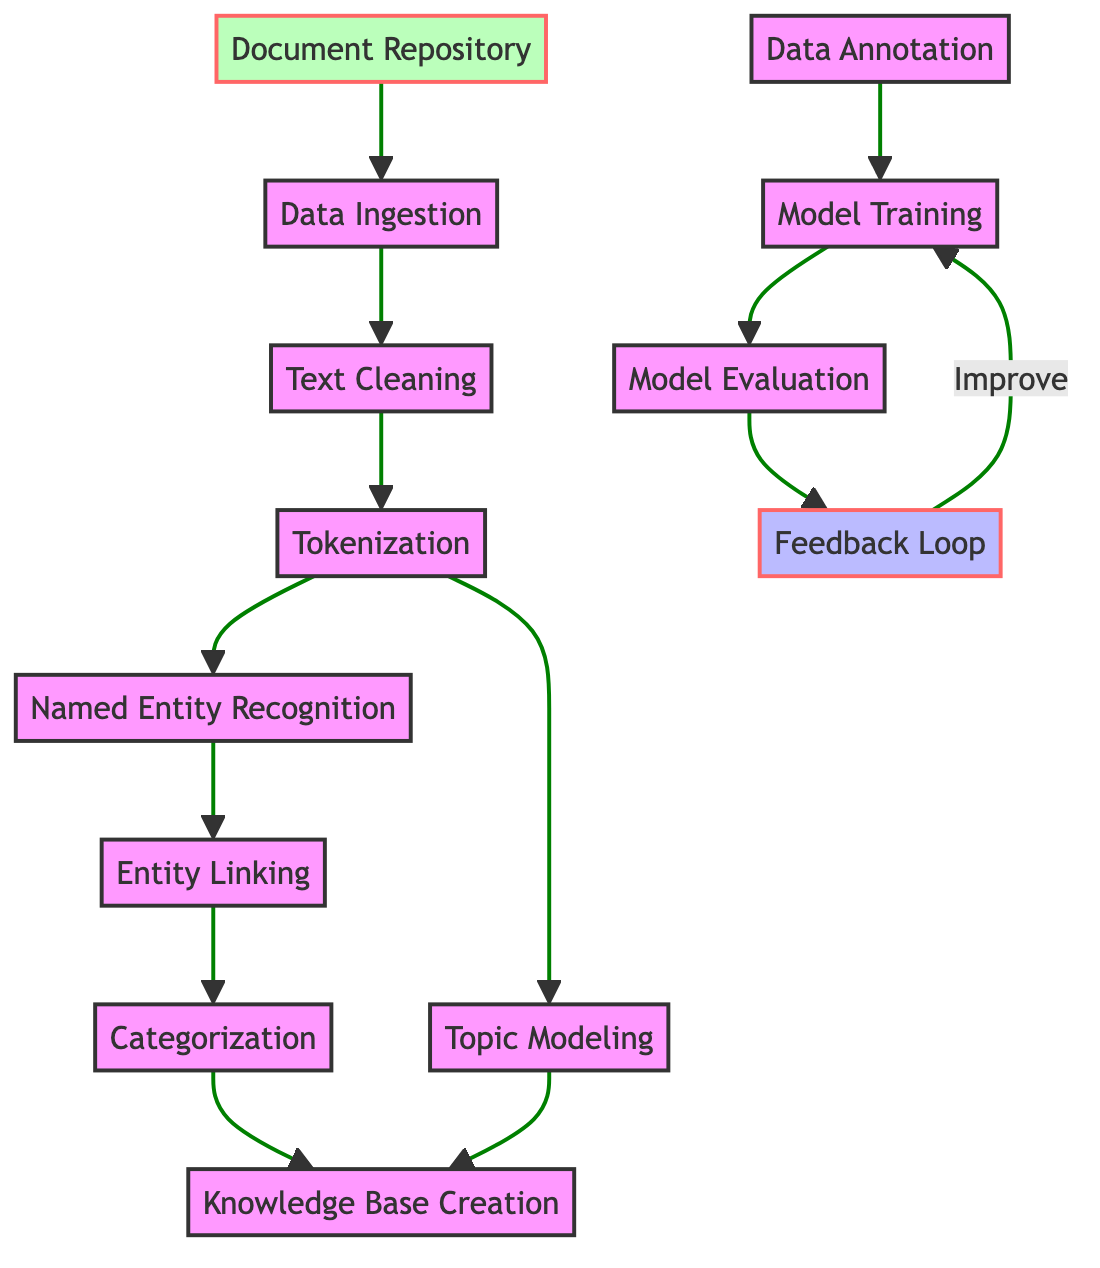What is the first step in the process? The first step in the process is labeled as "Data Ingestion", which is directly connected to the "Document Repository".
Answer: Data Ingestion How many steps are there in the process before creating the knowledge base? Counting from "Data Ingestion" to "Knowledge Base Creation," there are 7 steps (Data Ingestion, Text Cleaning, Tokenization, Named Entity Recognition, Entity Linking, Categorization, and Topic Modeling).
Answer: 7 What are the two outputs of the steps leading to the knowledge base? The outputs leading to the knowledge base are "Categorization" and "Topic Modeling," which both connect to "Knowledge Base Creation."
Answer: Categorization and Topic Modeling What process follows "Model Evaluation"? After "Model Evaluation," the next process is "Feedback Loop," which indicates a cyclical nature in improving the model based on evaluation.
Answer: Feedback Loop How is the feedback ingrained in the model training process? The feedback loop returns to "Model Training," indicating that improvements from "Model Evaluation" directly influence and enhance the model training phase.
Answer: Improve What is the significance of the "Data Annotation" step? "Data Annotation" is essential as it serves as the input for "Model Training", providing the necessary labeled data for the algorithms to learn from.
Answer: Input for Model Training Which steps can be considered data processing steps in the diagram? The data processing steps include "Data Ingestion," "Text Cleaning," "Tokenization," "Named Entity Recognition," "Entity Linking," "Categorization," "Topic Modeling," and "Model Training."
Answer: 8 steps What is connected to "Entity Linking"? The steps connected to "Entity Linking" are "Named Entity Recognition" and it leads to "Categorization," showing it as a transitional process for extracting and linking entities.
Answer: Categorization Which node represents the knowledge repository created from Dr. Wofsy's papers? The node that represents the knowledge repository created from Dr. Wofsy's papers is "Knowledge Base Creation."
Answer: Knowledge Base Creation 